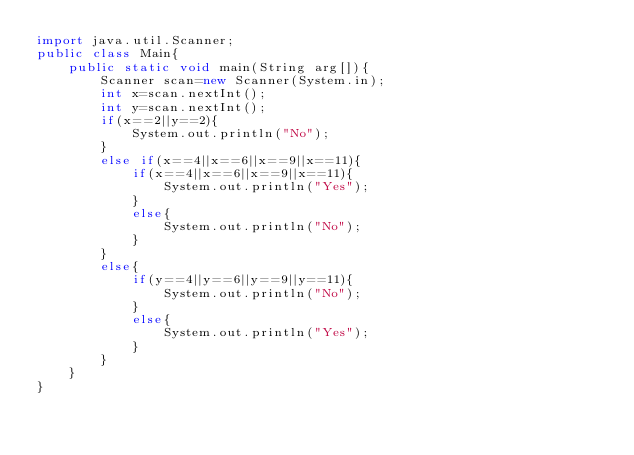Convert code to text. <code><loc_0><loc_0><loc_500><loc_500><_Java_>import java.util.Scanner;
public class Main{
    public static void main(String arg[]){
        Scanner scan=new Scanner(System.in);
        int x=scan.nextInt();
        int y=scan.nextInt();
        if(x==2||y==2){
            System.out.println("No");
        }
        else if(x==4||x==6||x==9||x==11){
            if(x==4||x==6||x==9||x==11){
                System.out.println("Yes");
            }
            else{
                System.out.println("No");
            }
        }
        else{
            if(y==4||y==6||y==9||y==11){
                System.out.println("No");
            }
            else{
                System.out.println("Yes");
            }
        }
    }
}</code> 